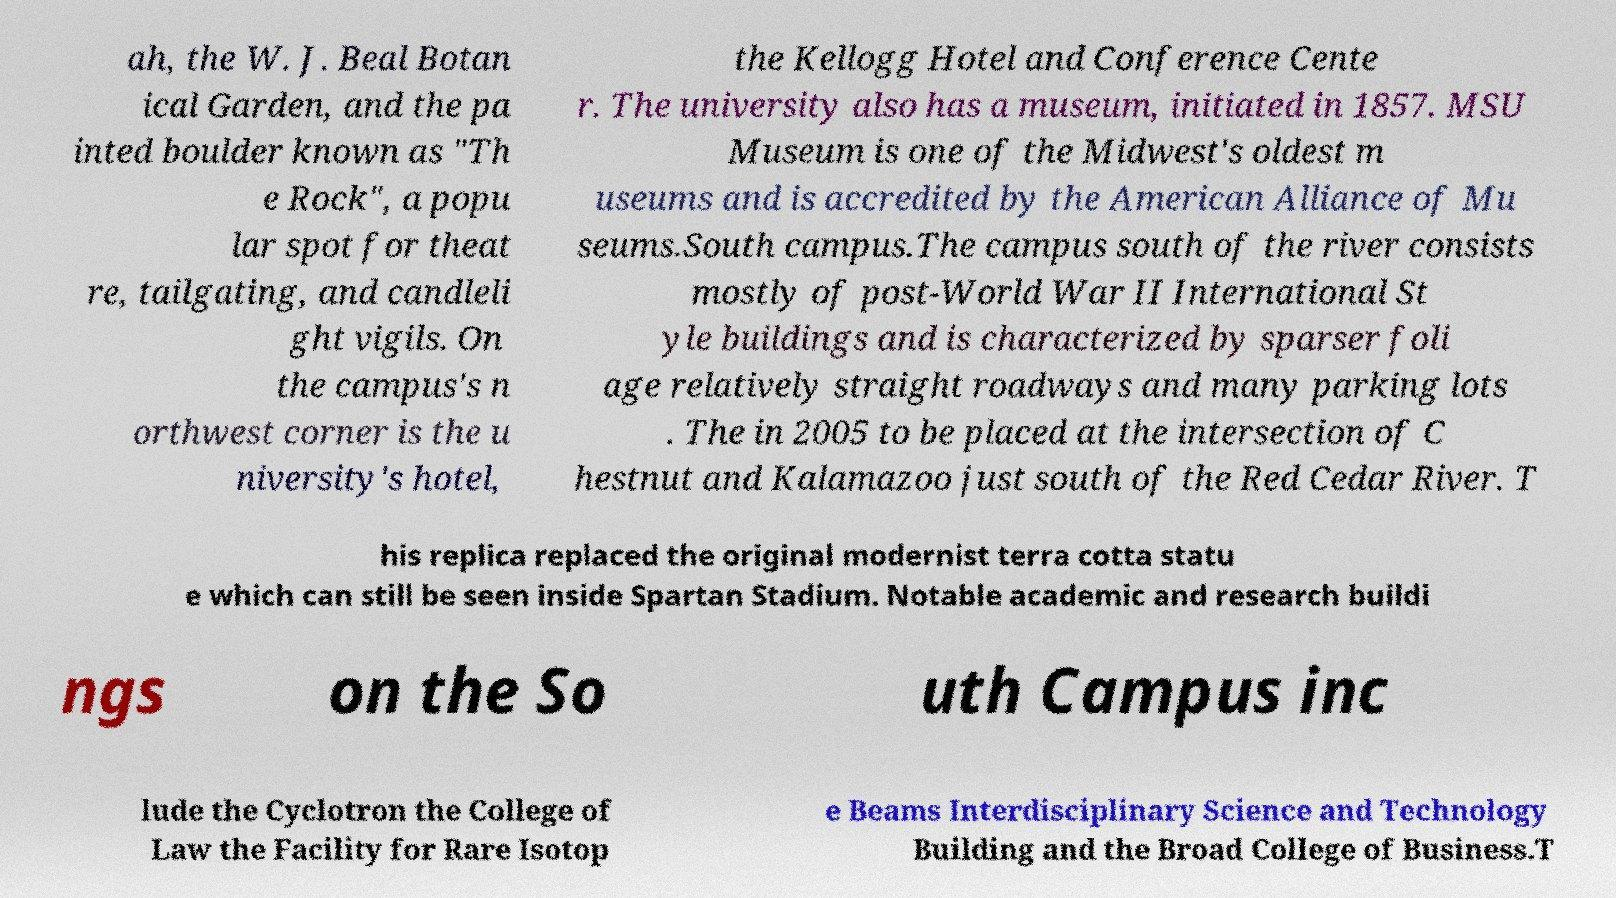I need the written content from this picture converted into text. Can you do that? ah, the W. J. Beal Botan ical Garden, and the pa inted boulder known as "Th e Rock", a popu lar spot for theat re, tailgating, and candleli ght vigils. On the campus's n orthwest corner is the u niversity's hotel, the Kellogg Hotel and Conference Cente r. The university also has a museum, initiated in 1857. MSU Museum is one of the Midwest's oldest m useums and is accredited by the American Alliance of Mu seums.South campus.The campus south of the river consists mostly of post-World War II International St yle buildings and is characterized by sparser foli age relatively straight roadways and many parking lots . The in 2005 to be placed at the intersection of C hestnut and Kalamazoo just south of the Red Cedar River. T his replica replaced the original modernist terra cotta statu e which can still be seen inside Spartan Stadium. Notable academic and research buildi ngs on the So uth Campus inc lude the Cyclotron the College of Law the Facility for Rare Isotop e Beams Interdisciplinary Science and Technology Building and the Broad College of Business.T 